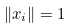Convert formula to latex. <formula><loc_0><loc_0><loc_500><loc_500>\| x _ { i } \| = 1</formula> 